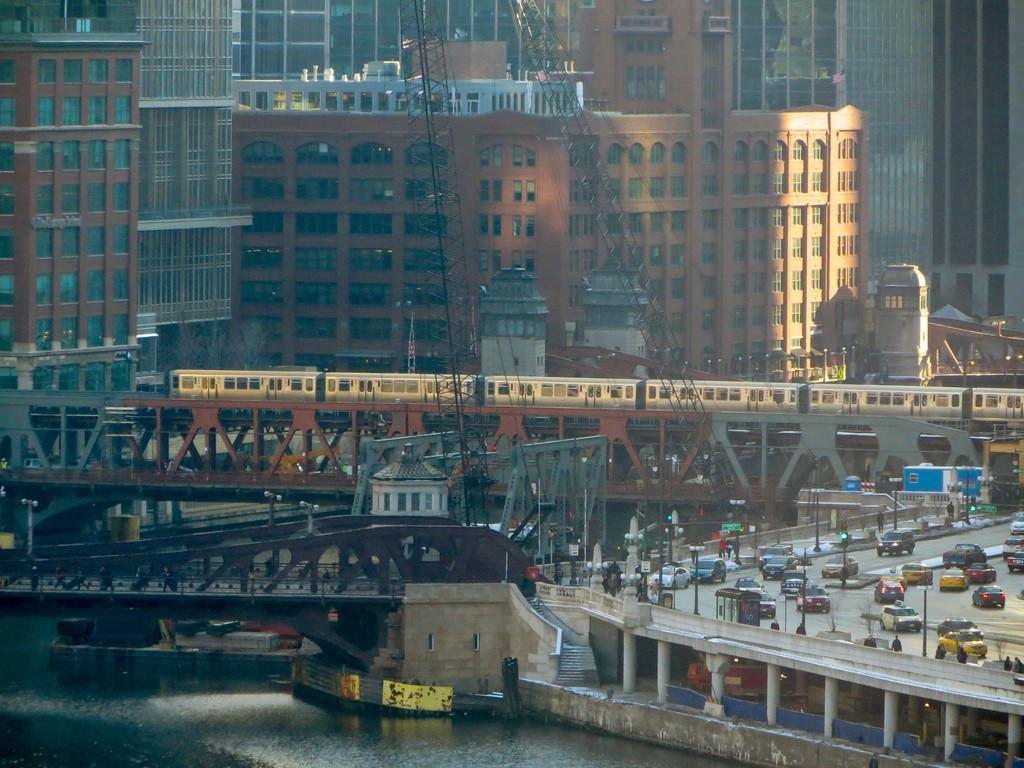Can you describe this image briefly? In this image we can see a few buildings, there are bridges above the water, we can see a few vehicles on the road and also we can see some pillars, poles, boards, windows, cranes and a train. 